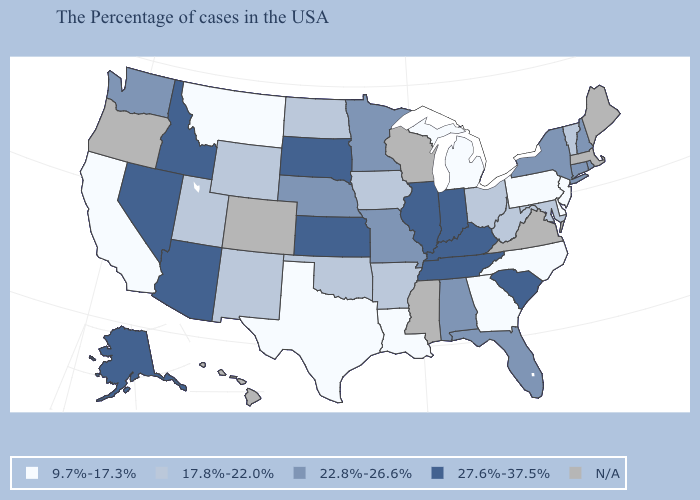What is the value of Arkansas?
Be succinct. 17.8%-22.0%. Name the states that have a value in the range 27.6%-37.5%?
Concise answer only. South Carolina, Kentucky, Indiana, Tennessee, Illinois, Kansas, South Dakota, Arizona, Idaho, Nevada, Alaska. Which states have the highest value in the USA?
Give a very brief answer. South Carolina, Kentucky, Indiana, Tennessee, Illinois, Kansas, South Dakota, Arizona, Idaho, Nevada, Alaska. What is the value of Maryland?
Quick response, please. 17.8%-22.0%. Which states have the lowest value in the USA?
Keep it brief. New Jersey, Delaware, Pennsylvania, North Carolina, Georgia, Michigan, Louisiana, Texas, Montana, California. What is the lowest value in states that border North Carolina?
Short answer required. 9.7%-17.3%. What is the value of Rhode Island?
Be succinct. 22.8%-26.6%. What is the value of Georgia?
Concise answer only. 9.7%-17.3%. What is the highest value in the South ?
Concise answer only. 27.6%-37.5%. Among the states that border Missouri , does Kentucky have the highest value?
Keep it brief. Yes. Does South Dakota have the lowest value in the USA?
Quick response, please. No. What is the highest value in the USA?
Quick response, please. 27.6%-37.5%. Does New Jersey have the lowest value in the Northeast?
Write a very short answer. Yes. 